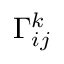<formula> <loc_0><loc_0><loc_500><loc_500>\Gamma _ { i j } ^ { k }</formula> 